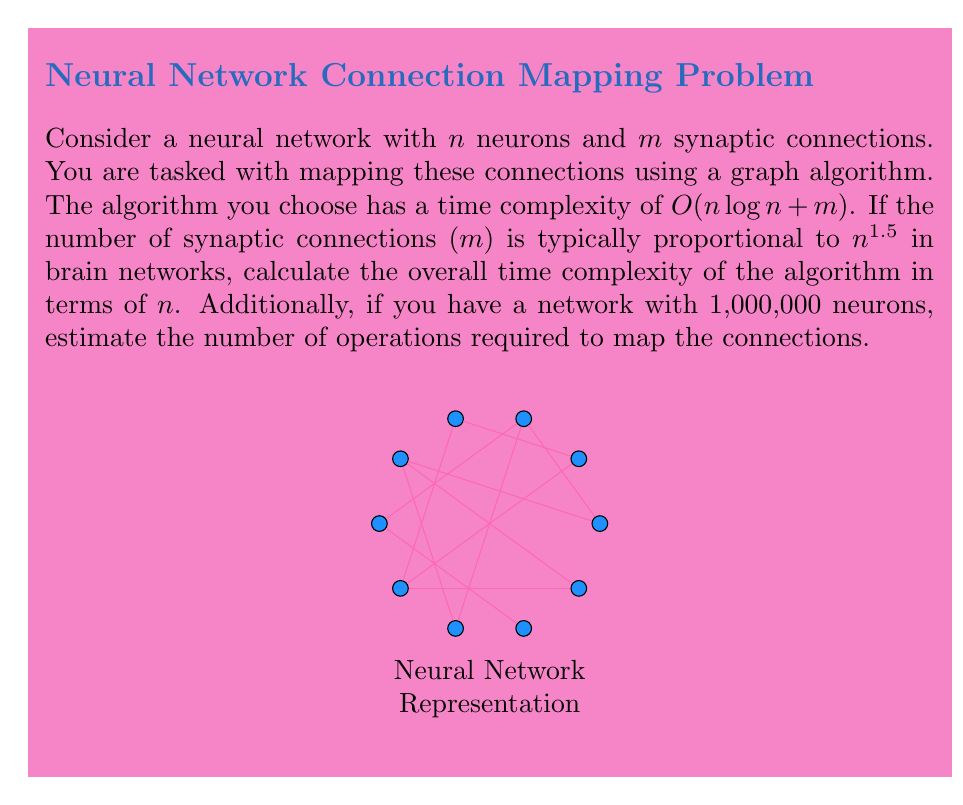Help me with this question. Let's approach this step-by-step:

1) We're given that the time complexity of the algorithm is $O(n \log n + m)$.

2) We're also told that $m$ is proportional to $n^{1.5}$, which means $m = cn^{1.5}$ for some constant $c$.

3) Substituting this into our time complexity:
   $O(n \log n + cn^{1.5})$

4) In Big O notation, we can drop constant factors, so this becomes:
   $O(n \log n + n^{1.5})$

5) Now, we need to determine which term dominates as $n$ grows large. We can see that $n^{1.5}$ grows faster than $n \log n$, so it will dominate for large $n$.

6) Therefore, the overall time complexity simplifies to:
   $O(n^{1.5})$

7) For the second part of the question, with 1,000,000 neurons:
   $n = 1,000,000 = 10^6$

8) The number of operations will be proportional to $n^{1.5}$:
   $(10^6)^{1.5} = 10^9$

Therefore, the algorithm will require on the order of 1 billion operations to map the connections in a network with 1,000,000 neurons.
Answer: $O(n^{1.5})$; $\approx 10^9$ operations for 1,000,000 neurons 